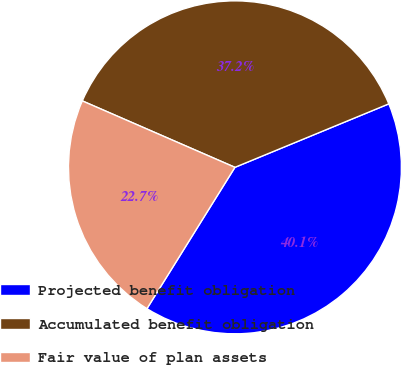<chart> <loc_0><loc_0><loc_500><loc_500><pie_chart><fcel>Projected benefit obligation<fcel>Accumulated benefit obligation<fcel>Fair value of plan assets<nl><fcel>40.09%<fcel>37.24%<fcel>22.67%<nl></chart> 